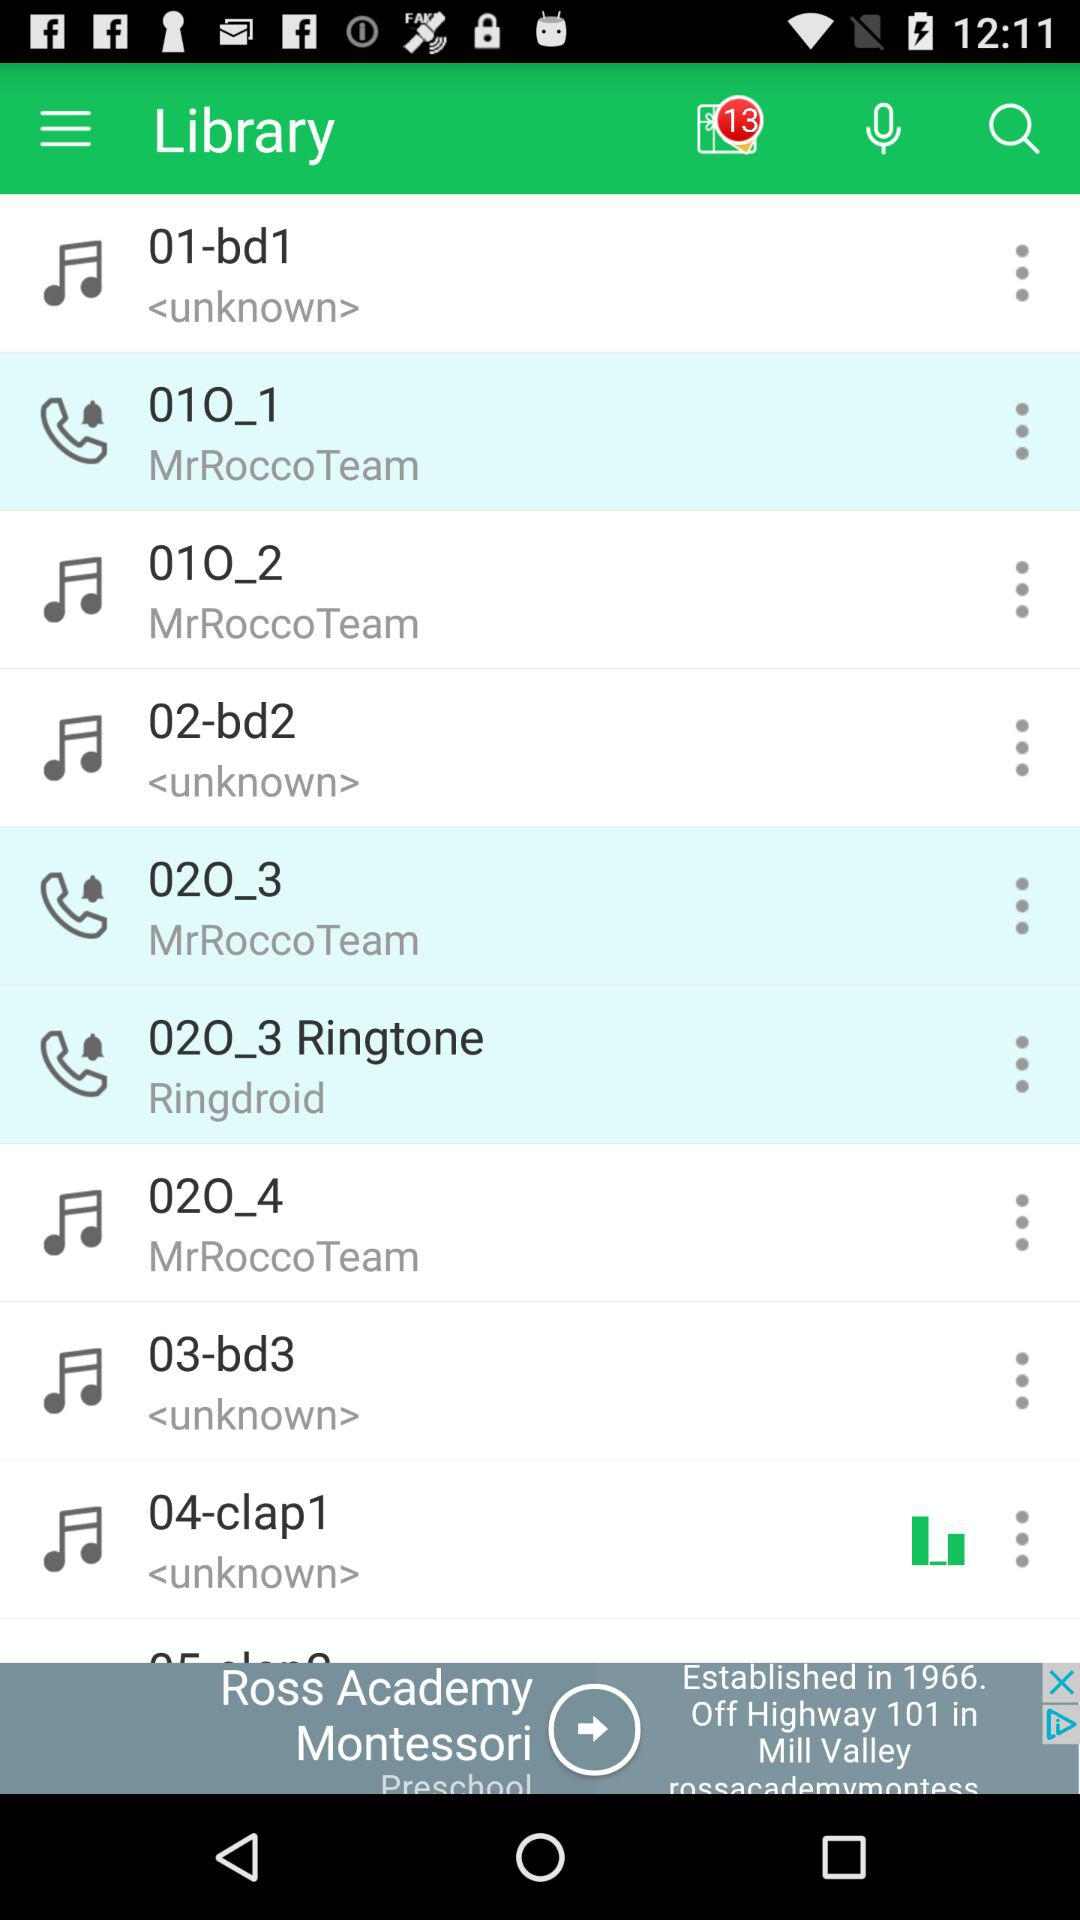How long is the song currently playing?
When the provided information is insufficient, respond with <no answer>. <no answer> 